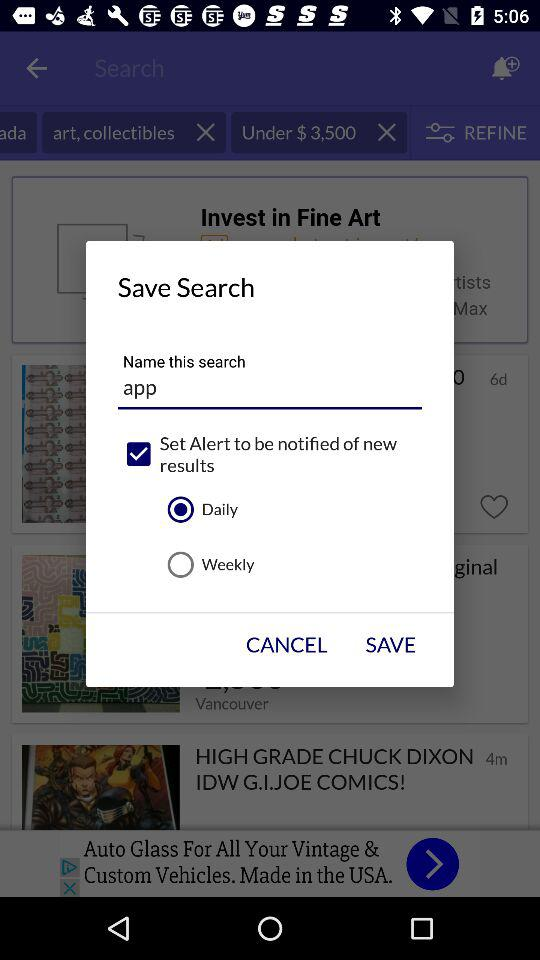How many audios are there? There are 42,726 audios. 